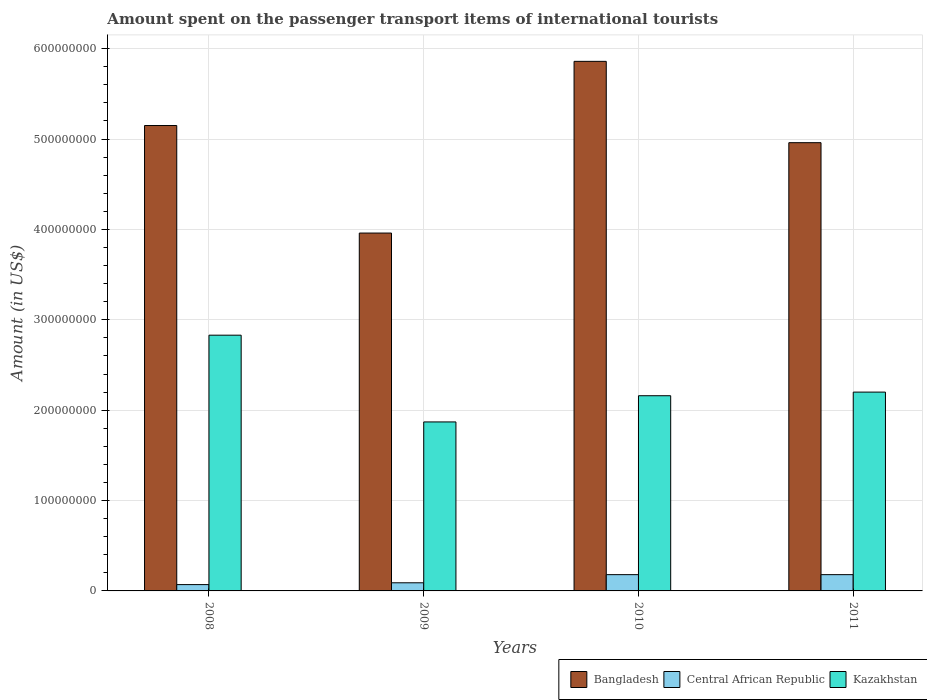How many different coloured bars are there?
Offer a terse response. 3. Are the number of bars per tick equal to the number of legend labels?
Keep it short and to the point. Yes. What is the amount spent on the passenger transport items of international tourists in Bangladesh in 2010?
Offer a very short reply. 5.86e+08. Across all years, what is the maximum amount spent on the passenger transport items of international tourists in Bangladesh?
Ensure brevity in your answer.  5.86e+08. Across all years, what is the minimum amount spent on the passenger transport items of international tourists in Kazakhstan?
Give a very brief answer. 1.87e+08. In which year was the amount spent on the passenger transport items of international tourists in Central African Republic maximum?
Your answer should be very brief. 2010. In which year was the amount spent on the passenger transport items of international tourists in Bangladesh minimum?
Provide a short and direct response. 2009. What is the total amount spent on the passenger transport items of international tourists in Central African Republic in the graph?
Your answer should be compact. 5.20e+07. What is the difference between the amount spent on the passenger transport items of international tourists in Bangladesh in 2009 and that in 2011?
Ensure brevity in your answer.  -1.00e+08. What is the difference between the amount spent on the passenger transport items of international tourists in Kazakhstan in 2010 and the amount spent on the passenger transport items of international tourists in Bangladesh in 2009?
Keep it short and to the point. -1.80e+08. What is the average amount spent on the passenger transport items of international tourists in Kazakhstan per year?
Provide a succinct answer. 2.26e+08. In the year 2011, what is the difference between the amount spent on the passenger transport items of international tourists in Bangladesh and amount spent on the passenger transport items of international tourists in Central African Republic?
Ensure brevity in your answer.  4.78e+08. In how many years, is the amount spent on the passenger transport items of international tourists in Bangladesh greater than 200000000 US$?
Your response must be concise. 4. What is the ratio of the amount spent on the passenger transport items of international tourists in Bangladesh in 2008 to that in 2009?
Make the answer very short. 1.3. Is the amount spent on the passenger transport items of international tourists in Bangladesh in 2010 less than that in 2011?
Your answer should be compact. No. Is the difference between the amount spent on the passenger transport items of international tourists in Bangladesh in 2008 and 2011 greater than the difference between the amount spent on the passenger transport items of international tourists in Central African Republic in 2008 and 2011?
Provide a short and direct response. Yes. What is the difference between the highest and the second highest amount spent on the passenger transport items of international tourists in Kazakhstan?
Offer a terse response. 6.30e+07. What is the difference between the highest and the lowest amount spent on the passenger transport items of international tourists in Bangladesh?
Offer a terse response. 1.90e+08. In how many years, is the amount spent on the passenger transport items of international tourists in Kazakhstan greater than the average amount spent on the passenger transport items of international tourists in Kazakhstan taken over all years?
Keep it short and to the point. 1. What does the 3rd bar from the left in 2009 represents?
Your answer should be very brief. Kazakhstan. What does the 1st bar from the right in 2008 represents?
Your answer should be very brief. Kazakhstan. Is it the case that in every year, the sum of the amount spent on the passenger transport items of international tourists in Kazakhstan and amount spent on the passenger transport items of international tourists in Bangladesh is greater than the amount spent on the passenger transport items of international tourists in Central African Republic?
Make the answer very short. Yes. Are all the bars in the graph horizontal?
Ensure brevity in your answer.  No. How many years are there in the graph?
Give a very brief answer. 4. What is the difference between two consecutive major ticks on the Y-axis?
Provide a short and direct response. 1.00e+08. Does the graph contain any zero values?
Your answer should be compact. No. Where does the legend appear in the graph?
Ensure brevity in your answer.  Bottom right. How are the legend labels stacked?
Provide a short and direct response. Horizontal. What is the title of the graph?
Your answer should be compact. Amount spent on the passenger transport items of international tourists. What is the label or title of the X-axis?
Your response must be concise. Years. What is the label or title of the Y-axis?
Offer a very short reply. Amount (in US$). What is the Amount (in US$) of Bangladesh in 2008?
Keep it short and to the point. 5.15e+08. What is the Amount (in US$) in Central African Republic in 2008?
Offer a very short reply. 7.00e+06. What is the Amount (in US$) in Kazakhstan in 2008?
Make the answer very short. 2.83e+08. What is the Amount (in US$) in Bangladesh in 2009?
Give a very brief answer. 3.96e+08. What is the Amount (in US$) in Central African Republic in 2009?
Your response must be concise. 9.00e+06. What is the Amount (in US$) in Kazakhstan in 2009?
Your answer should be very brief. 1.87e+08. What is the Amount (in US$) in Bangladesh in 2010?
Keep it short and to the point. 5.86e+08. What is the Amount (in US$) of Central African Republic in 2010?
Your answer should be compact. 1.80e+07. What is the Amount (in US$) in Kazakhstan in 2010?
Your response must be concise. 2.16e+08. What is the Amount (in US$) in Bangladesh in 2011?
Your answer should be compact. 4.96e+08. What is the Amount (in US$) in Central African Republic in 2011?
Give a very brief answer. 1.80e+07. What is the Amount (in US$) in Kazakhstan in 2011?
Provide a short and direct response. 2.20e+08. Across all years, what is the maximum Amount (in US$) of Bangladesh?
Offer a very short reply. 5.86e+08. Across all years, what is the maximum Amount (in US$) in Central African Republic?
Provide a short and direct response. 1.80e+07. Across all years, what is the maximum Amount (in US$) in Kazakhstan?
Your answer should be very brief. 2.83e+08. Across all years, what is the minimum Amount (in US$) in Bangladesh?
Your response must be concise. 3.96e+08. Across all years, what is the minimum Amount (in US$) of Kazakhstan?
Keep it short and to the point. 1.87e+08. What is the total Amount (in US$) of Bangladesh in the graph?
Ensure brevity in your answer.  1.99e+09. What is the total Amount (in US$) of Central African Republic in the graph?
Give a very brief answer. 5.20e+07. What is the total Amount (in US$) in Kazakhstan in the graph?
Provide a succinct answer. 9.06e+08. What is the difference between the Amount (in US$) in Bangladesh in 2008 and that in 2009?
Ensure brevity in your answer.  1.19e+08. What is the difference between the Amount (in US$) in Kazakhstan in 2008 and that in 2009?
Ensure brevity in your answer.  9.60e+07. What is the difference between the Amount (in US$) in Bangladesh in 2008 and that in 2010?
Your response must be concise. -7.10e+07. What is the difference between the Amount (in US$) in Central African Republic in 2008 and that in 2010?
Offer a terse response. -1.10e+07. What is the difference between the Amount (in US$) in Kazakhstan in 2008 and that in 2010?
Your answer should be very brief. 6.70e+07. What is the difference between the Amount (in US$) in Bangladesh in 2008 and that in 2011?
Your response must be concise. 1.90e+07. What is the difference between the Amount (in US$) in Central African Republic in 2008 and that in 2011?
Your answer should be very brief. -1.10e+07. What is the difference between the Amount (in US$) of Kazakhstan in 2008 and that in 2011?
Give a very brief answer. 6.30e+07. What is the difference between the Amount (in US$) in Bangladesh in 2009 and that in 2010?
Provide a succinct answer. -1.90e+08. What is the difference between the Amount (in US$) of Central African Republic in 2009 and that in 2010?
Offer a terse response. -9.00e+06. What is the difference between the Amount (in US$) of Kazakhstan in 2009 and that in 2010?
Make the answer very short. -2.90e+07. What is the difference between the Amount (in US$) in Bangladesh in 2009 and that in 2011?
Your answer should be compact. -1.00e+08. What is the difference between the Amount (in US$) in Central African Republic in 2009 and that in 2011?
Ensure brevity in your answer.  -9.00e+06. What is the difference between the Amount (in US$) of Kazakhstan in 2009 and that in 2011?
Ensure brevity in your answer.  -3.30e+07. What is the difference between the Amount (in US$) of Bangladesh in 2010 and that in 2011?
Keep it short and to the point. 9.00e+07. What is the difference between the Amount (in US$) in Central African Republic in 2010 and that in 2011?
Offer a very short reply. 0. What is the difference between the Amount (in US$) in Bangladesh in 2008 and the Amount (in US$) in Central African Republic in 2009?
Give a very brief answer. 5.06e+08. What is the difference between the Amount (in US$) of Bangladesh in 2008 and the Amount (in US$) of Kazakhstan in 2009?
Your answer should be very brief. 3.28e+08. What is the difference between the Amount (in US$) of Central African Republic in 2008 and the Amount (in US$) of Kazakhstan in 2009?
Make the answer very short. -1.80e+08. What is the difference between the Amount (in US$) in Bangladesh in 2008 and the Amount (in US$) in Central African Republic in 2010?
Make the answer very short. 4.97e+08. What is the difference between the Amount (in US$) of Bangladesh in 2008 and the Amount (in US$) of Kazakhstan in 2010?
Your response must be concise. 2.99e+08. What is the difference between the Amount (in US$) in Central African Republic in 2008 and the Amount (in US$) in Kazakhstan in 2010?
Make the answer very short. -2.09e+08. What is the difference between the Amount (in US$) in Bangladesh in 2008 and the Amount (in US$) in Central African Republic in 2011?
Offer a very short reply. 4.97e+08. What is the difference between the Amount (in US$) of Bangladesh in 2008 and the Amount (in US$) of Kazakhstan in 2011?
Make the answer very short. 2.95e+08. What is the difference between the Amount (in US$) of Central African Republic in 2008 and the Amount (in US$) of Kazakhstan in 2011?
Give a very brief answer. -2.13e+08. What is the difference between the Amount (in US$) in Bangladesh in 2009 and the Amount (in US$) in Central African Republic in 2010?
Your answer should be compact. 3.78e+08. What is the difference between the Amount (in US$) of Bangladesh in 2009 and the Amount (in US$) of Kazakhstan in 2010?
Make the answer very short. 1.80e+08. What is the difference between the Amount (in US$) in Central African Republic in 2009 and the Amount (in US$) in Kazakhstan in 2010?
Make the answer very short. -2.07e+08. What is the difference between the Amount (in US$) of Bangladesh in 2009 and the Amount (in US$) of Central African Republic in 2011?
Your answer should be compact. 3.78e+08. What is the difference between the Amount (in US$) of Bangladesh in 2009 and the Amount (in US$) of Kazakhstan in 2011?
Your response must be concise. 1.76e+08. What is the difference between the Amount (in US$) in Central African Republic in 2009 and the Amount (in US$) in Kazakhstan in 2011?
Your answer should be compact. -2.11e+08. What is the difference between the Amount (in US$) in Bangladesh in 2010 and the Amount (in US$) in Central African Republic in 2011?
Make the answer very short. 5.68e+08. What is the difference between the Amount (in US$) of Bangladesh in 2010 and the Amount (in US$) of Kazakhstan in 2011?
Provide a succinct answer. 3.66e+08. What is the difference between the Amount (in US$) of Central African Republic in 2010 and the Amount (in US$) of Kazakhstan in 2011?
Provide a short and direct response. -2.02e+08. What is the average Amount (in US$) of Bangladesh per year?
Offer a very short reply. 4.98e+08. What is the average Amount (in US$) of Central African Republic per year?
Give a very brief answer. 1.30e+07. What is the average Amount (in US$) of Kazakhstan per year?
Give a very brief answer. 2.26e+08. In the year 2008, what is the difference between the Amount (in US$) in Bangladesh and Amount (in US$) in Central African Republic?
Give a very brief answer. 5.08e+08. In the year 2008, what is the difference between the Amount (in US$) in Bangladesh and Amount (in US$) in Kazakhstan?
Offer a terse response. 2.32e+08. In the year 2008, what is the difference between the Amount (in US$) in Central African Republic and Amount (in US$) in Kazakhstan?
Your answer should be very brief. -2.76e+08. In the year 2009, what is the difference between the Amount (in US$) of Bangladesh and Amount (in US$) of Central African Republic?
Provide a short and direct response. 3.87e+08. In the year 2009, what is the difference between the Amount (in US$) in Bangladesh and Amount (in US$) in Kazakhstan?
Provide a succinct answer. 2.09e+08. In the year 2009, what is the difference between the Amount (in US$) of Central African Republic and Amount (in US$) of Kazakhstan?
Offer a very short reply. -1.78e+08. In the year 2010, what is the difference between the Amount (in US$) in Bangladesh and Amount (in US$) in Central African Republic?
Offer a very short reply. 5.68e+08. In the year 2010, what is the difference between the Amount (in US$) in Bangladesh and Amount (in US$) in Kazakhstan?
Provide a short and direct response. 3.70e+08. In the year 2010, what is the difference between the Amount (in US$) in Central African Republic and Amount (in US$) in Kazakhstan?
Make the answer very short. -1.98e+08. In the year 2011, what is the difference between the Amount (in US$) in Bangladesh and Amount (in US$) in Central African Republic?
Ensure brevity in your answer.  4.78e+08. In the year 2011, what is the difference between the Amount (in US$) of Bangladesh and Amount (in US$) of Kazakhstan?
Make the answer very short. 2.76e+08. In the year 2011, what is the difference between the Amount (in US$) of Central African Republic and Amount (in US$) of Kazakhstan?
Provide a succinct answer. -2.02e+08. What is the ratio of the Amount (in US$) in Bangladesh in 2008 to that in 2009?
Give a very brief answer. 1.3. What is the ratio of the Amount (in US$) in Central African Republic in 2008 to that in 2009?
Your answer should be very brief. 0.78. What is the ratio of the Amount (in US$) in Kazakhstan in 2008 to that in 2009?
Keep it short and to the point. 1.51. What is the ratio of the Amount (in US$) in Bangladesh in 2008 to that in 2010?
Offer a very short reply. 0.88. What is the ratio of the Amount (in US$) of Central African Republic in 2008 to that in 2010?
Make the answer very short. 0.39. What is the ratio of the Amount (in US$) in Kazakhstan in 2008 to that in 2010?
Offer a very short reply. 1.31. What is the ratio of the Amount (in US$) in Bangladesh in 2008 to that in 2011?
Offer a terse response. 1.04. What is the ratio of the Amount (in US$) of Central African Republic in 2008 to that in 2011?
Your answer should be compact. 0.39. What is the ratio of the Amount (in US$) of Kazakhstan in 2008 to that in 2011?
Keep it short and to the point. 1.29. What is the ratio of the Amount (in US$) of Bangladesh in 2009 to that in 2010?
Offer a very short reply. 0.68. What is the ratio of the Amount (in US$) of Central African Republic in 2009 to that in 2010?
Give a very brief answer. 0.5. What is the ratio of the Amount (in US$) of Kazakhstan in 2009 to that in 2010?
Make the answer very short. 0.87. What is the ratio of the Amount (in US$) of Bangladesh in 2009 to that in 2011?
Your answer should be very brief. 0.8. What is the ratio of the Amount (in US$) in Kazakhstan in 2009 to that in 2011?
Keep it short and to the point. 0.85. What is the ratio of the Amount (in US$) of Bangladesh in 2010 to that in 2011?
Provide a short and direct response. 1.18. What is the ratio of the Amount (in US$) of Central African Republic in 2010 to that in 2011?
Offer a very short reply. 1. What is the ratio of the Amount (in US$) in Kazakhstan in 2010 to that in 2011?
Your answer should be very brief. 0.98. What is the difference between the highest and the second highest Amount (in US$) in Bangladesh?
Provide a succinct answer. 7.10e+07. What is the difference between the highest and the second highest Amount (in US$) in Kazakhstan?
Ensure brevity in your answer.  6.30e+07. What is the difference between the highest and the lowest Amount (in US$) in Bangladesh?
Keep it short and to the point. 1.90e+08. What is the difference between the highest and the lowest Amount (in US$) in Central African Republic?
Your response must be concise. 1.10e+07. What is the difference between the highest and the lowest Amount (in US$) in Kazakhstan?
Provide a short and direct response. 9.60e+07. 